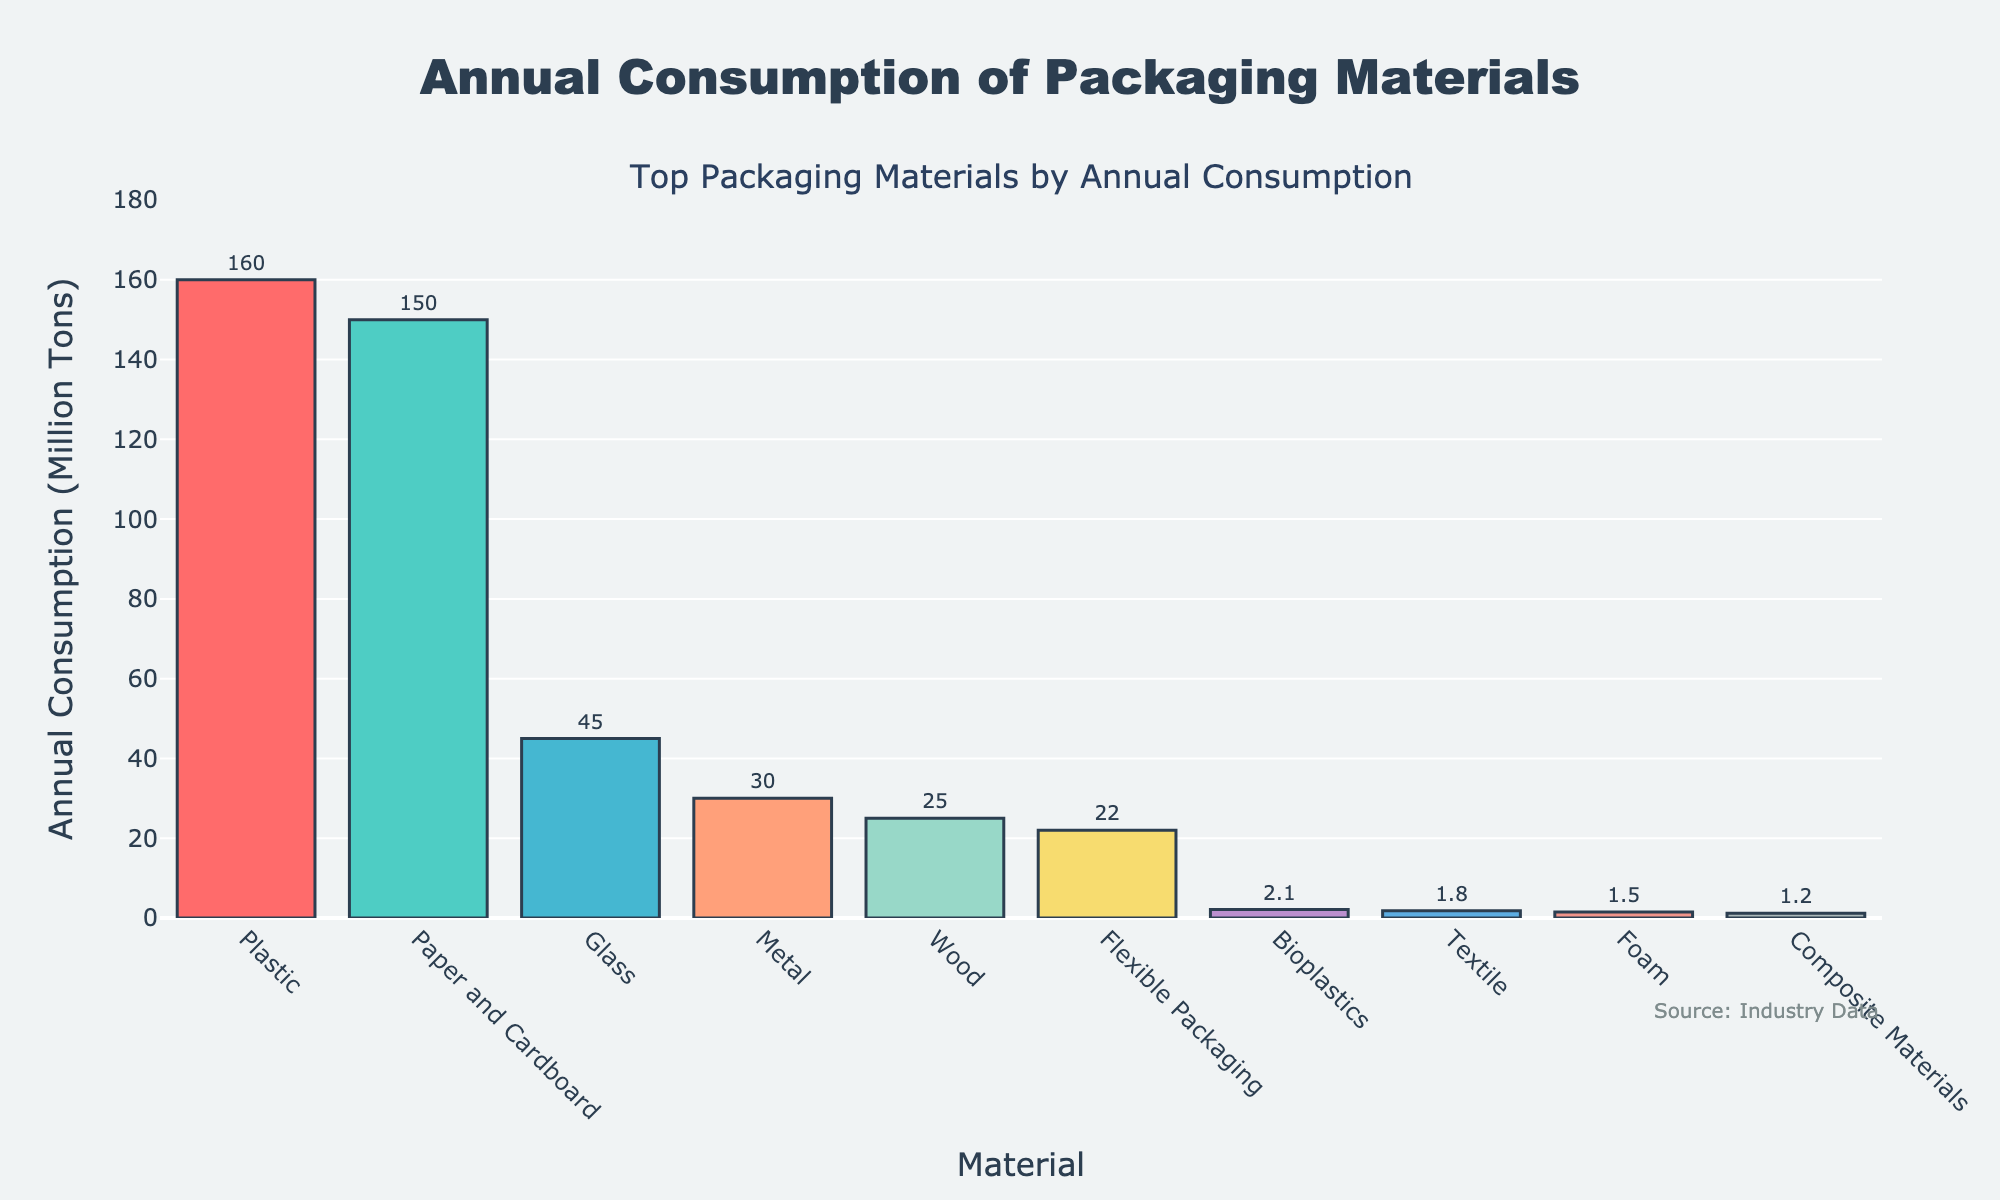What's the total annual consumption of the top three materials? The top three materials are Plastic (160 million tons), Paper and Cardboard (150 million tons), and Glass (45 million tons). Adding these together: 160 + 150 + 45 = 355 million tons.
Answer: 355 million tons Which material has higher annual consumption, Metal or Wood? The figure shows Metal with 30 million tons and Wood with 25 million tons, so Metal has higher annual consumption.
Answer: Metal What's the difference in annual consumption between Plastic and Bioplastics? Plastic has an annual consumption of 160 million tons while Bioplastics have 2.1 million tons. The difference is 160 - 2.1 = 157.9 million tons.
Answer: 157.9 million tons Which material ranks fourth in annual consumption? The materials are ranked by their annual consumption. The fourth one in the sorted list is Metal with 30 million tons.
Answer: Metal Which materials consume less than 5 million tons annually? The materials with annual consumption less than 5 million tons are Bioplastics (2.1 million tons), Textile (1.8 million tons), Foam (1.5 million tons), and Composite Materials (1.2 million tons).
Answer: Bioplastics, Textile, Foam, Composite Materials What’s the sum of the annual consumption for Flexible Packaging and Textile? Flexible Packaging has an annual consumption of 22 million tons and Textile has 1.8 million tons. Adding these together: 22 + 1.8 = 23.8 million tons.
Answer: 23.8 million tons What percentage of the total annual consumption does Paper and Cardboard represent? The total annual consumption is the sum of all materials, which is 160 + 150 + 45 + 30 + 25 + 22 + 2.1 + 1.8 + 1.5 + 1.2 = 438.6 million tons. Paper and Cardboard's percentage is (150 / 438.6) * 100 ≈ 34.2%.
Answer: 34.2% Which material is colored yellow in the figure? The yellow bar in the figure represents Flexible Packaging with 22 million tons of annual consumption.
Answer: Flexible Packaging 